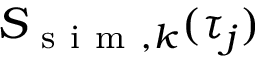Convert formula to latex. <formula><loc_0><loc_0><loc_500><loc_500>S _ { s i m , k } ( \tau _ { j } )</formula> 